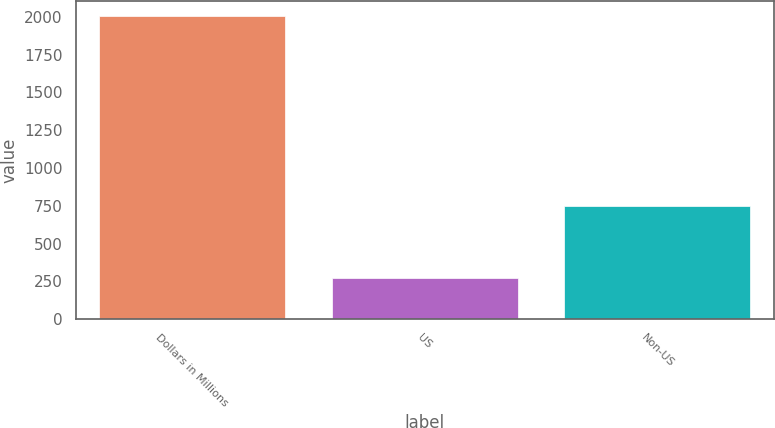Convert chart. <chart><loc_0><loc_0><loc_500><loc_500><bar_chart><fcel>Dollars in Millions<fcel>US<fcel>Non-US<nl><fcel>2007<fcel>274<fcel>751<nl></chart> 